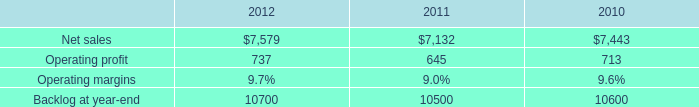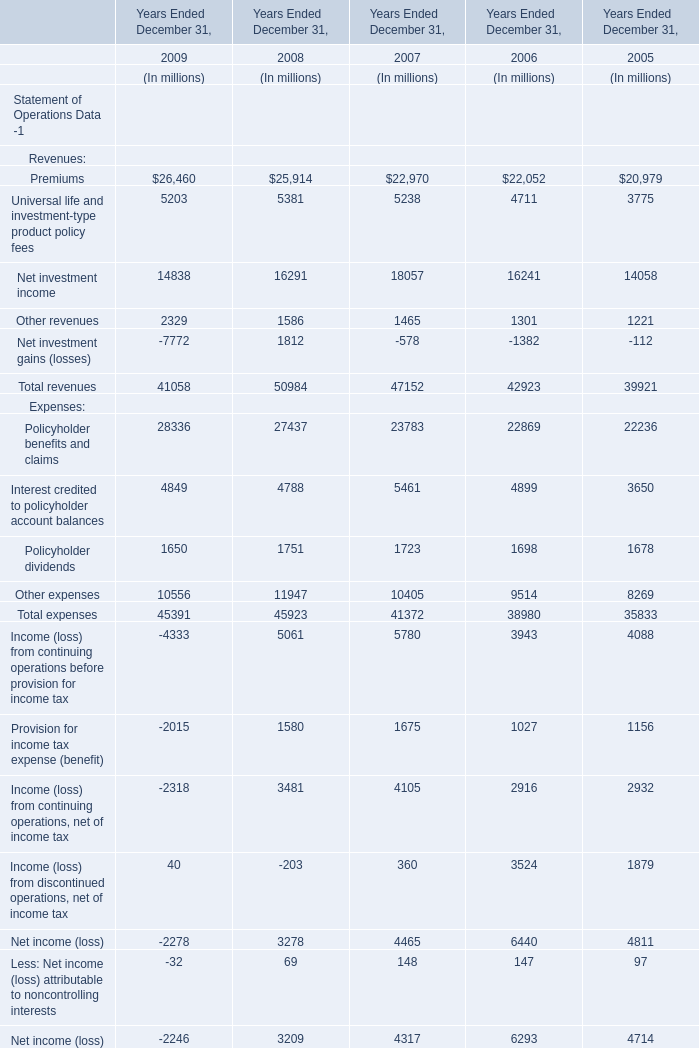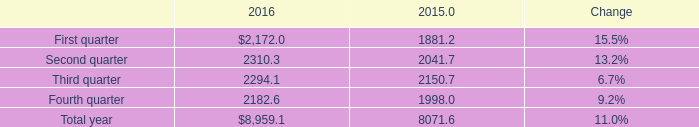What is the difference between 2009 and 2008 's highest Premiums? (in million) 
Computations: (26460 - 25914)
Answer: 546.0. 